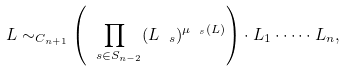Convert formula to latex. <formula><loc_0><loc_0><loc_500><loc_500>L \sim _ { C _ { n + 1 } } \left ( \prod _ { \ s \in S _ { n - 2 } } ( L _ { \ s } ) ^ { \mu _ { \ s } ( L ) } \right ) \cdot L _ { 1 } \cdot \dots \cdot L _ { n } ,</formula> 